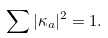Convert formula to latex. <formula><loc_0><loc_0><loc_500><loc_500>\sum | \kappa _ { a } | ^ { 2 } = 1 .</formula> 